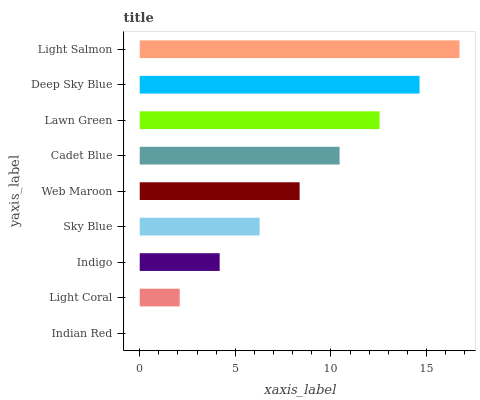Is Indian Red the minimum?
Answer yes or no. Yes. Is Light Salmon the maximum?
Answer yes or no. Yes. Is Light Coral the minimum?
Answer yes or no. No. Is Light Coral the maximum?
Answer yes or no. No. Is Light Coral greater than Indian Red?
Answer yes or no. Yes. Is Indian Red less than Light Coral?
Answer yes or no. Yes. Is Indian Red greater than Light Coral?
Answer yes or no. No. Is Light Coral less than Indian Red?
Answer yes or no. No. Is Web Maroon the high median?
Answer yes or no. Yes. Is Web Maroon the low median?
Answer yes or no. Yes. Is Indian Red the high median?
Answer yes or no. No. Is Lawn Green the low median?
Answer yes or no. No. 